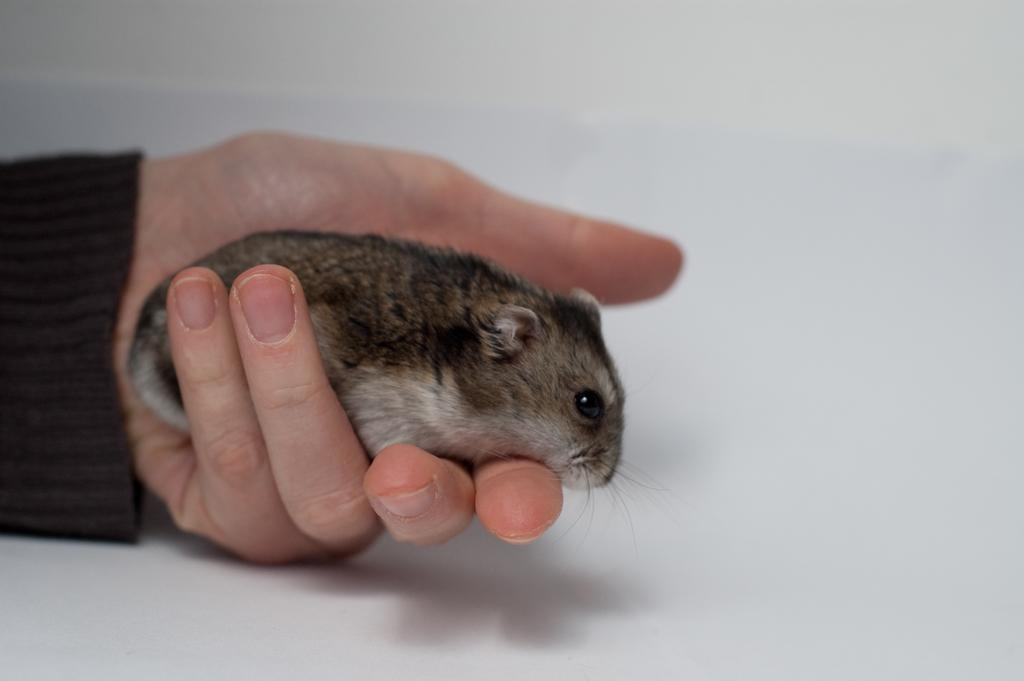What can be seen in the image? There is a person's hand in the image. What is the hand holding? The hand is holding a rat. What type of health benefits can be gained from the snails in the image? There are no snails present in the image; it only features a person's hand holding a rat. 